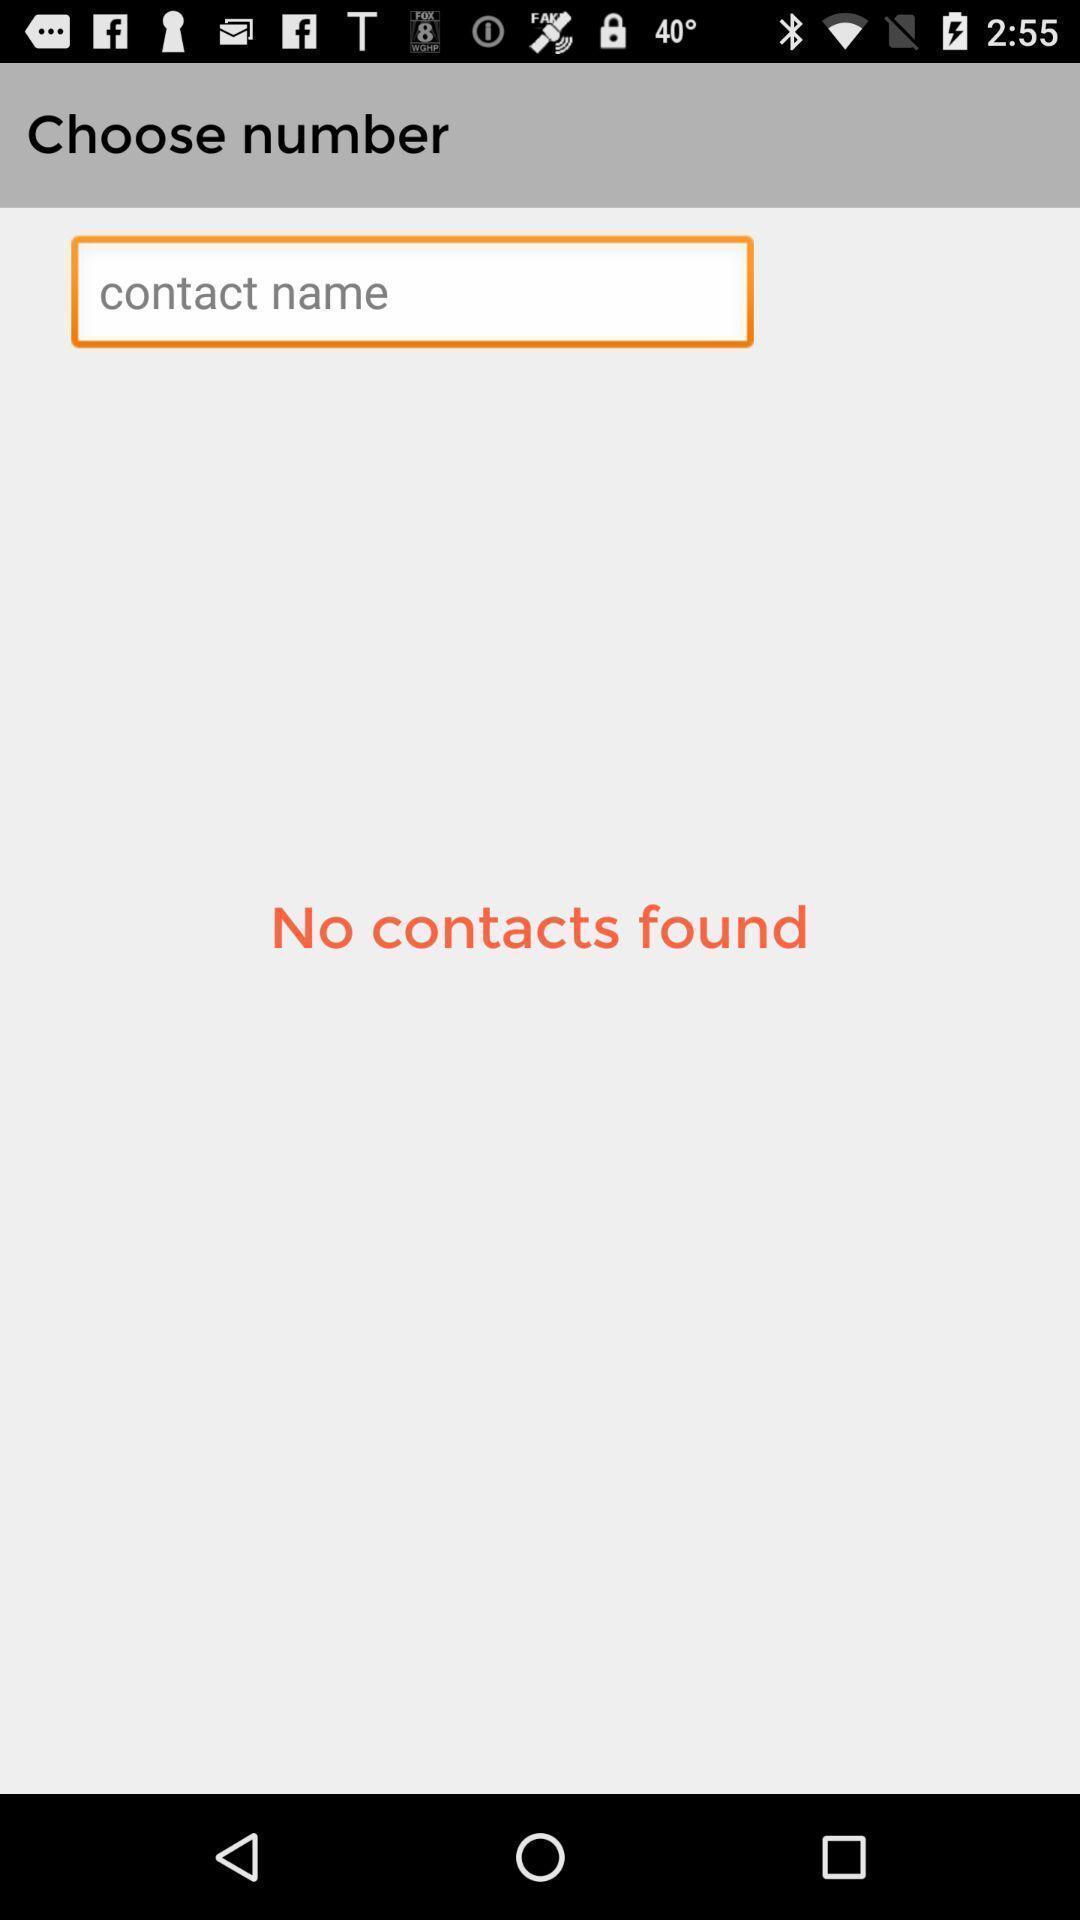Provide a description of this screenshot. Page displaying search option for contacts. 